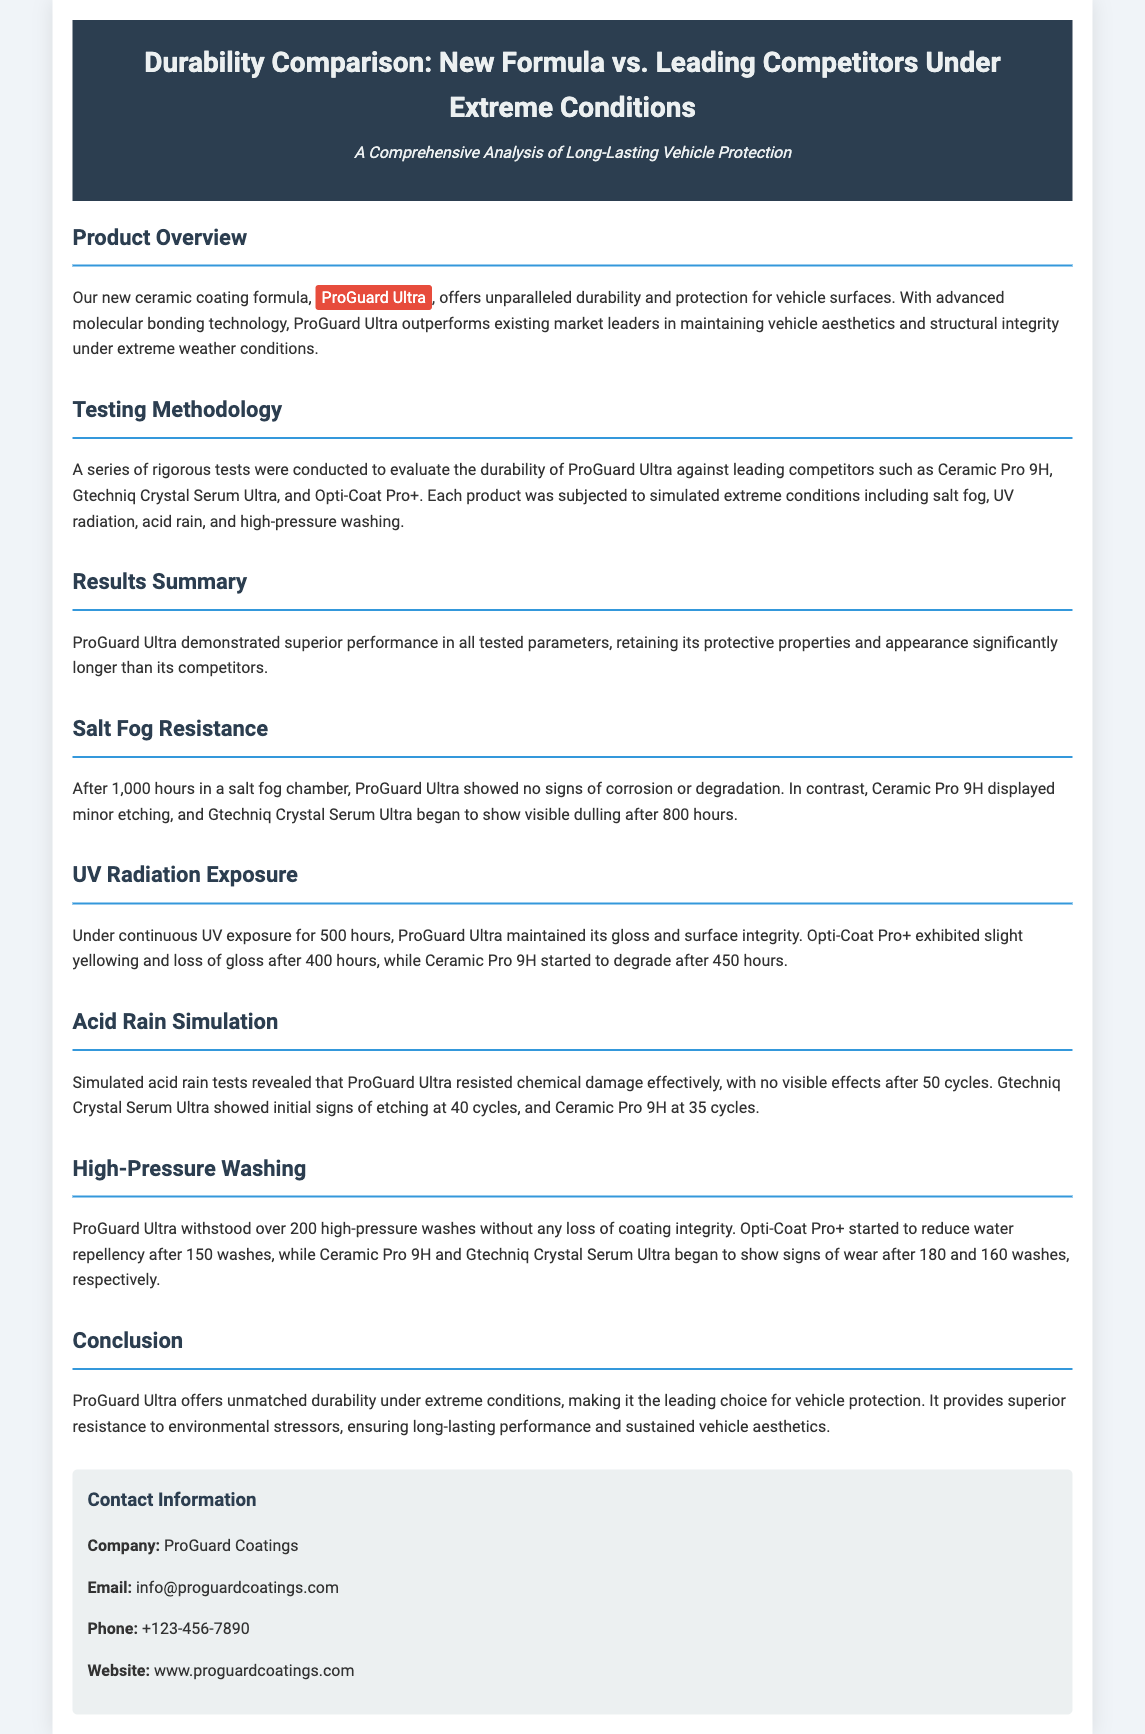What is the name of the new ceramic coating formula? The document states the name of the new ceramic coating formula is ProGuard Ultra.
Answer: ProGuard Ultra Which competitors were tested alongside ProGuard Ultra? The competitors mentioned in the document are Ceramic Pro 9H, Gtechniq Crystal Serum Ultra, and Opti-Coat Pro+.
Answer: Ceramic Pro 9H, Gtechniq Crystal Serum Ultra, Opti-Coat Pro+ How many hours did ProGuard Ultra withstand in the salt fog chamber? The document mentions that ProGuard Ultra showed no signs of corrosion or degradation after 1,000 hours in a salt fog chamber.
Answer: 1,000 hours After how many high-pressure washes did ProGuard Ultra show no loss of coating integrity? ProGuard Ultra withstood over 200 high-pressure washes without any loss of coating integrity.
Answer: 200 What effect did 500 hours of UV exposure have on ProGuard Ultra? The document states that under continuous UV exposure for 500 hours, ProGuard Ultra maintained its gloss and surface integrity.
Answer: Maintained gloss and surface integrity How many cycles of acid rain did ProGuard Ultra withstand without visible effects? ProGuard Ultra resisted chemical damage effectively with no visible effects after 50 cycles of acid rain.
Answer: 50 cycles Which product started to degrade after 450 hours of UV exposure? According to the document, Ceramic Pro 9H started to degrade after 450 hours of UV exposure.
Answer: Ceramic Pro 9H What is the main conclusion about ProGuard Ultra's durability? The conclusion states that ProGuard Ultra offers unmatched durability under extreme conditions, making it the leading choice for vehicle protection.
Answer: Unmatched durability 